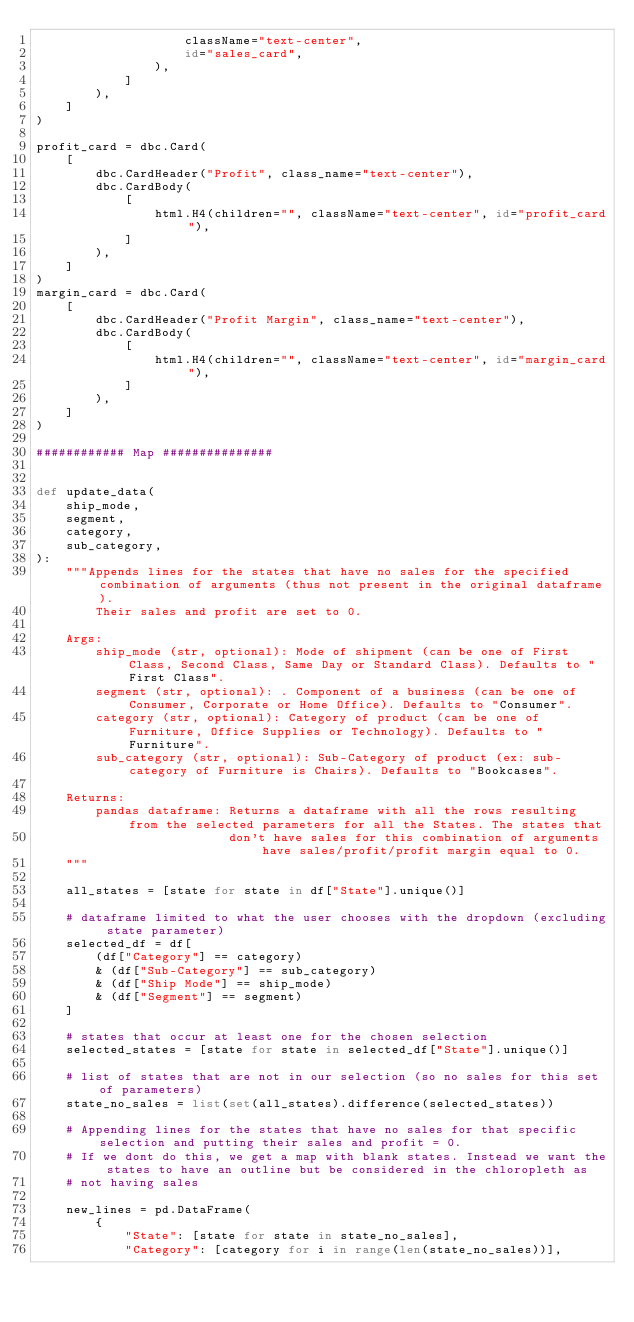<code> <loc_0><loc_0><loc_500><loc_500><_Python_>                    className="text-center",
                    id="sales_card",
                ),
            ]
        ),
    ]
)

profit_card = dbc.Card(
    [
        dbc.CardHeader("Profit", class_name="text-center"),
        dbc.CardBody(
            [
                html.H4(children="", className="text-center", id="profit_card"),
            ]
        ),
    ]
)
margin_card = dbc.Card(
    [
        dbc.CardHeader("Profit Margin", class_name="text-center"),
        dbc.CardBody(
            [
                html.H4(children="", className="text-center", id="margin_card"),
            ]
        ),
    ]
)

############ Map ###############


def update_data(
    ship_mode,
    segment,
    category,
    sub_category,
):
    """Appends lines for the states that have no sales for the specified combination of arguments (thus not present in the original dataframe).
        Their sales and profit are set to 0.

    Args:
        ship_mode (str, optional): Mode of shipment (can be one of First Class, Second Class, Same Day or Standard Class). Defaults to "First Class".
        segment (str, optional): . Component of a business (can be one of Consumer, Corporate or Home Office). Defaults to "Consumer".
        category (str, optional): Category of product (can be one of Furniture, Office Supplies or Technology). Defaults to "Furniture".
        sub_category (str, optional): Sub-Category of product (ex: sub-category of Furniture is Chairs). Defaults to "Bookcases".

    Returns:
        pandas dataframe: Returns a dataframe with all the rows resulting from the selected parameters for all the States. The states that
                          don't have sales for this combination of arguments have sales/profit/profit margin equal to 0.
    """

    all_states = [state for state in df["State"].unique()]

    # dataframe limited to what the user chooses with the dropdown (excluding state parameter)
    selected_df = df[
        (df["Category"] == category)
        & (df["Sub-Category"] == sub_category)
        & (df["Ship Mode"] == ship_mode)
        & (df["Segment"] == segment)
    ]

    # states that occur at least one for the chosen selection
    selected_states = [state for state in selected_df["State"].unique()]

    # list of states that are not in our selection (so no sales for this set of parameters)
    state_no_sales = list(set(all_states).difference(selected_states))

    # Appending lines for the states that have no sales for that specific selection and putting their sales and profit = 0.
    # If we dont do this, we get a map with blank states. Instead we want the states to have an outline but be considered in the chloropleth as
    # not having sales

    new_lines = pd.DataFrame(
        {
            "State": [state for state in state_no_sales],
            "Category": [category for i in range(len(state_no_sales))],</code> 